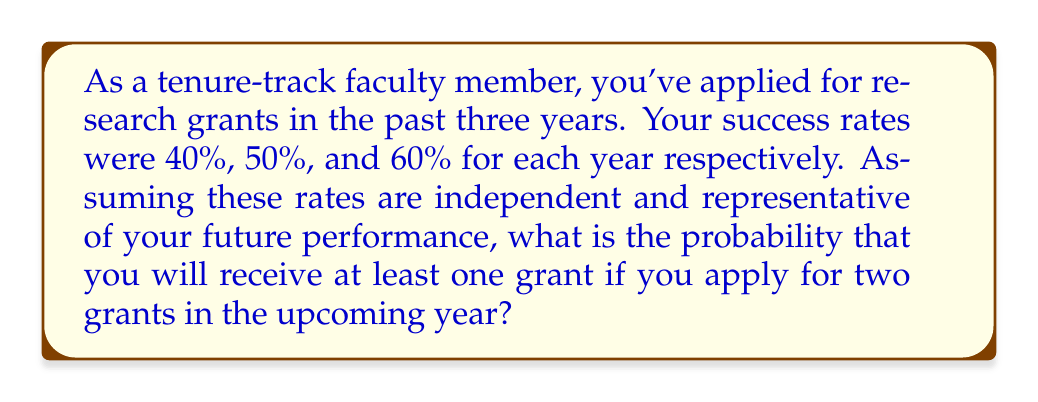Help me with this question. Let's approach this step-by-step:

1) First, we need to calculate your average success rate over the past three years:

   $$ \text{Average Success Rate} = \frac{40\% + 50\% + 60\%}{3} = 50\% = 0.5 $$

2) Now, we need to find the probability of receiving at least one grant out of two applications. It's often easier to calculate the probability of the complement event (receiving no grants) and then subtract from 1.

3) The probability of not receiving a grant on a single application is:

   $$ P(\text{No Grant}) = 1 - 0.5 = 0.5 $$

4) For two independent applications, the probability of receiving no grants is:

   $$ P(\text{No Grants}) = 0.5 \times 0.5 = 0.25 $$

5) Therefore, the probability of receiving at least one grant is:

   $$ P(\text{At Least One Grant}) = 1 - P(\text{No Grants}) = 1 - 0.25 = 0.75 $$

6) We can also verify this using the direct method:
   
   $$ P(\text{At Least One Grant}) = 1 - (1-0.5)^2 = 1 - 0.5^2 = 1 - 0.25 = 0.75 $$
Answer: 0.75 